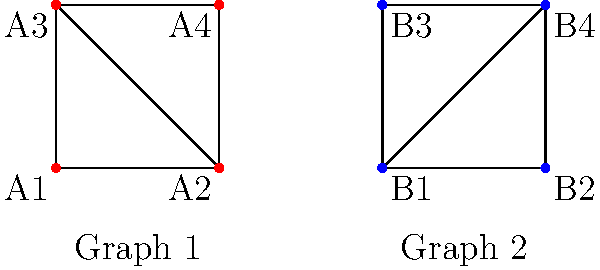As an illustrator incorporating photo textures from analog prints, you're developing a method to identify similar texture patterns using graph isomorphism. Two texture patterns are represented by the graphs shown above. Are these graphs isomorphic? If so, provide a bijective mapping between the vertices of Graph 1 and Graph 2 that preserves the edge structure. To determine if the graphs are isomorphic and find a bijective mapping, we'll follow these steps:

1. Check if the graphs have the same number of vertices and edges:
   - Both graphs have 4 vertices and 5 edges, so they pass this initial check.

2. Compare the degree sequences of both graphs:
   - Graph 1: A1(2), A2(3), A3(3), A4(2)
   - Graph 2: B1(3), B2(2), B3(2), B4(3)
   - The degree sequences match, so we continue.

3. Look for a bijective mapping that preserves the edge structure:
   - Vertices with degree 3 must map to each other: A2 ↔ B1, A3 ↔ B4
   - Vertices with degree 2 must map to each other: A1 ↔ B2, A4 ↔ B3

4. Verify that this mapping preserves the edge structure:
   - A1--A2 maps to B2--B1
   - A1--A3 maps to B2--B4
   - A2--A3 maps to B1--B4
   - A2--A4 maps to B1--B3
   - A3--A4 maps to B4--B3

The mapping preserves all edges, confirming that the graphs are isomorphic.
Answer: Yes, isomorphic. Mapping: A1↔B2, A2↔B1, A3↔B4, A4↔B3. 